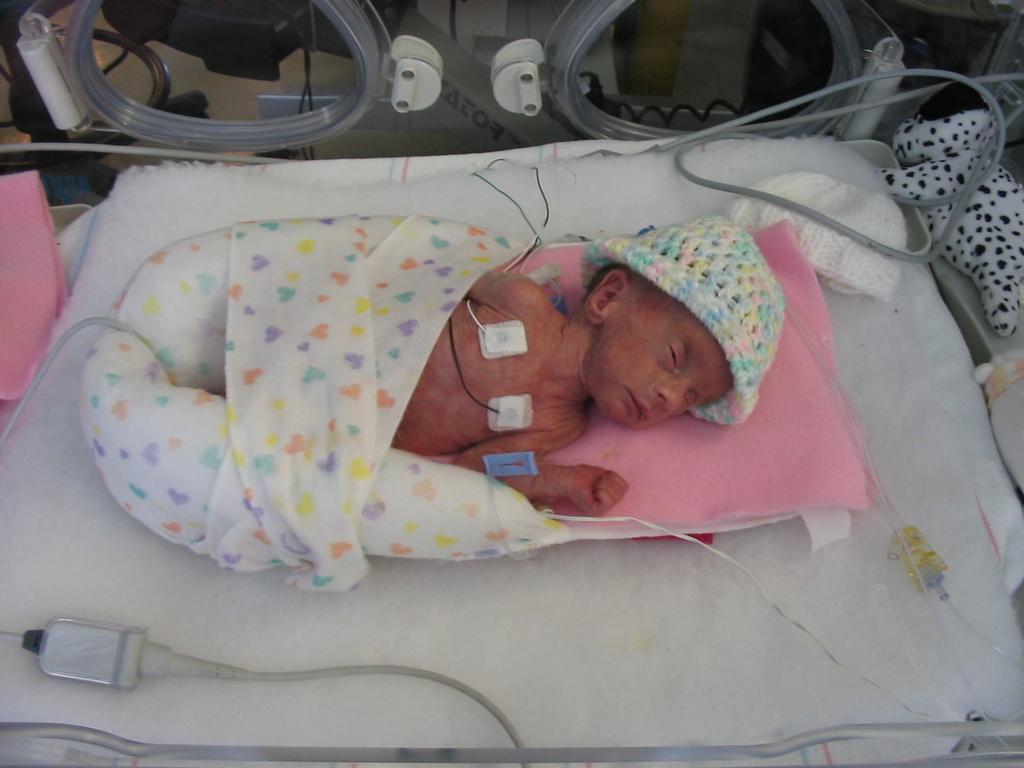How would you summarize this image in a sentence or two? In this image there is a small baby sleeping on the bed and there are a few cables of a hospital equipment is attached to the chest of a baby and there are toys and other objects are placed around the baby. 